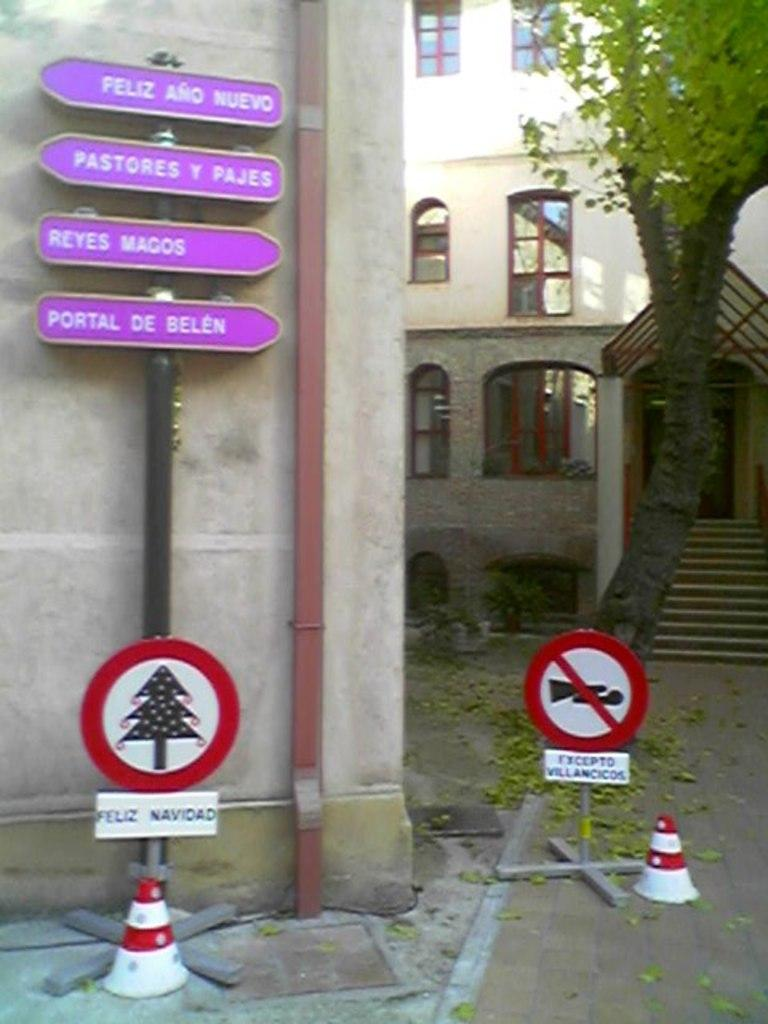<image>
Offer a succinct explanation of the picture presented. A little sign with a Christmas tree on it says "Feliz Navidad." 